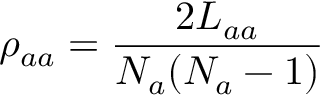Convert formula to latex. <formula><loc_0><loc_0><loc_500><loc_500>\rho _ { a a } = \frac { 2 L _ { a a } } { N _ { a } ( N _ { a } - 1 ) }</formula> 